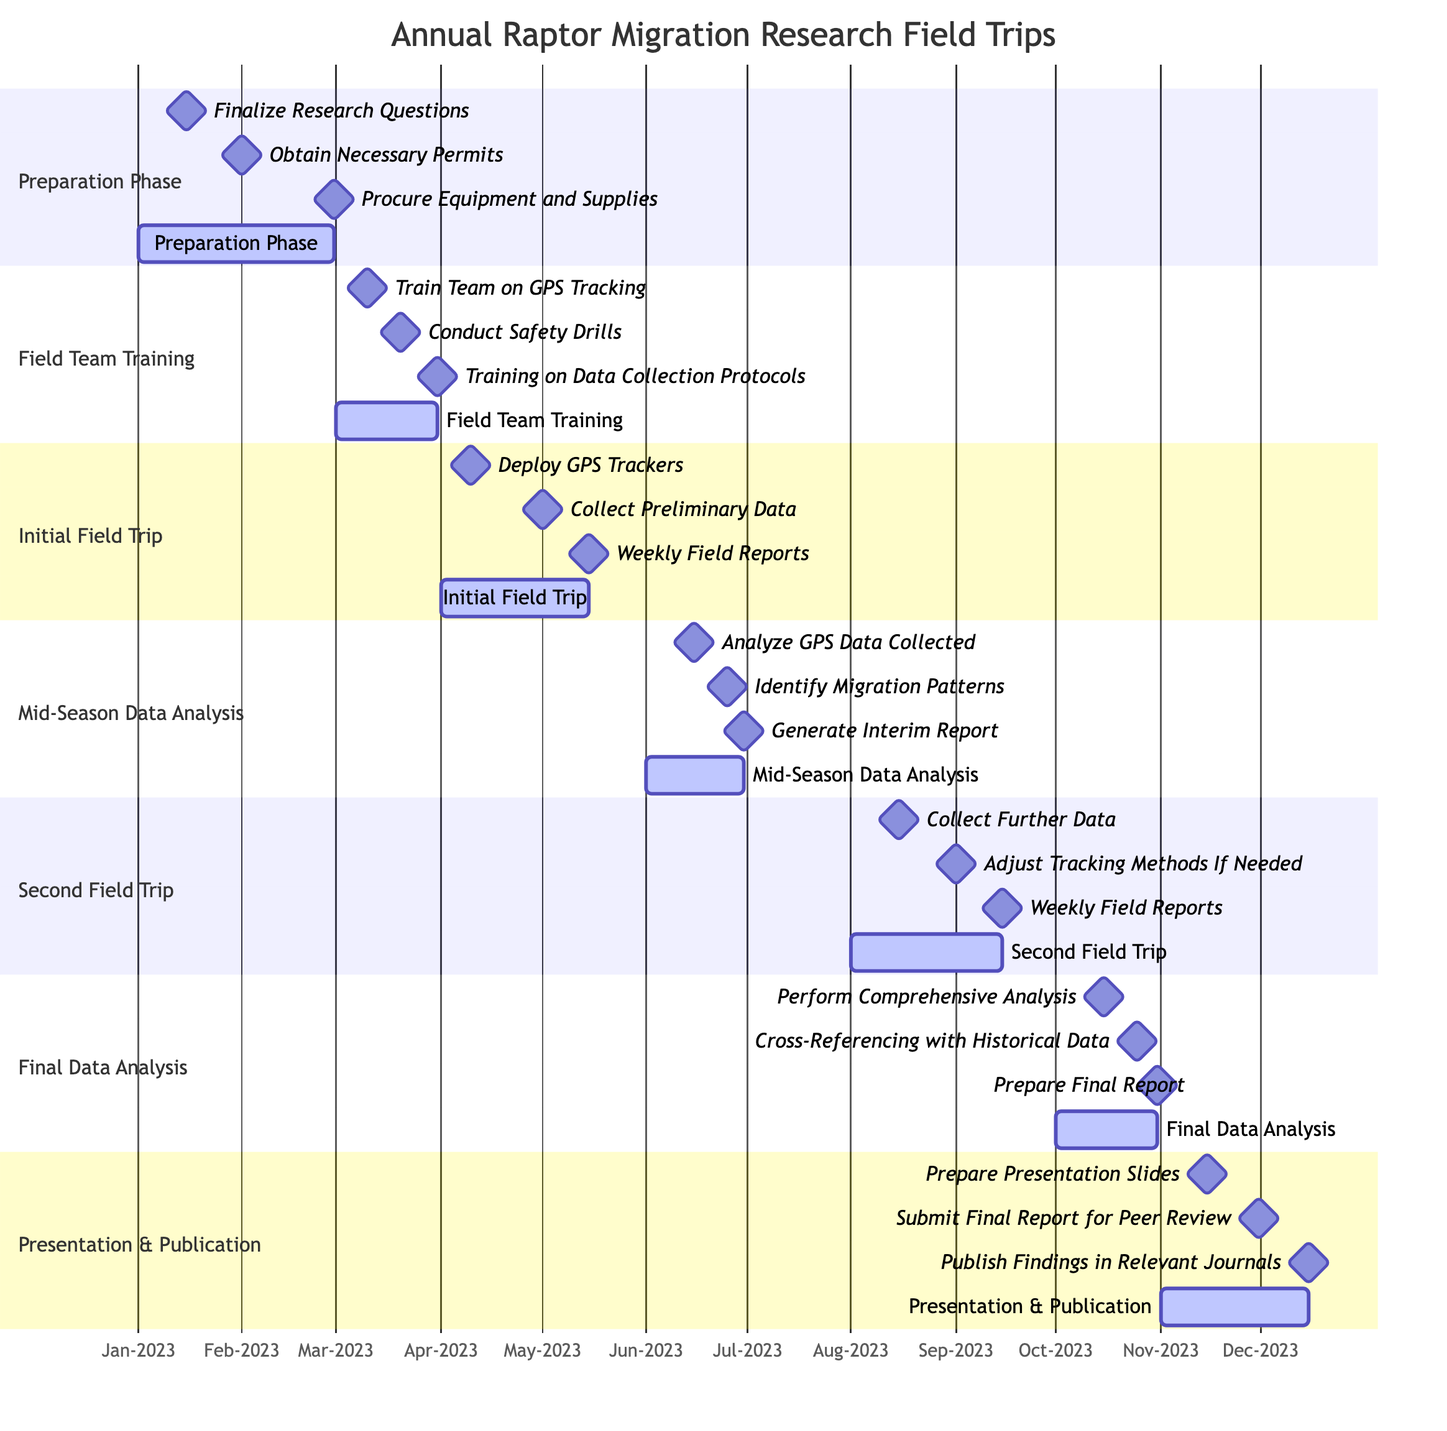What's the total number of phases in the Gantt chart? The Gantt chart has six sections: Preparation Phase, Field Team Training, Initial Field Trip, Mid-Season Data Analysis, Second Field Trip, Final Data Analysis, and Presentation & Publication. Counting these sections gives a total of six phases.
Answer: 6 What is the duration of the Initial Field Trip? The Initial Field Trip starts on April 1, 2023, and ends on May 15, 2023. The duration can be calculated from the start to the end date, which amounts to 45 days (15 days in April plus 15 days in May).
Answer: 45 days What milestone is scheduled for June 15, 2023? On June 15, 2023, the milestone "Preliminary GPS Data Analyzed" is scheduled as part of the Mid-Season Data Analysis. This can be confirmed by locating the date within that specific section of the Gantt chart.
Answer: Preliminary GPS Data Analyzed How many deliverables are there during the Field Team Training phase? The Field Team Training phase lists three deliverables: "Train Team on GPS Tracking," "Conduct Safety Drills," and "Training on Data Collection Protocols." Counting these items provides the total.
Answer: 3 Which deliverable is due immediately after the Second Field Trip? After the Second Field Trip, the deliverable is "Collect Further Data." This corresponds directly to the task in the Gantt chart as well as the sequencing of phases, thus identifying it clearly.
Answer: Collect Further Data When is the Final Report draft expected to be completed? The Final Report draft is expected to be completed by October 31, 2023, as indicated in the Final Data Analysis section of the Gantt chart. The deadline aligns with the end date of that section, making it clear.
Answer: October 31, 2023 Which phase includes the "Submit Final Report for Peer Review" milestone? The milestone "Submit Final Report for Peer Review" occurs in the Presentation & Publication phase. Examining the milestones listed within this phase confirms whereabouts of the specific milestone in the visual representation.
Answer: Presentation & Publication What is the timeframe for the Mid-Season Data Analysis? The Mid-Season Data Analysis timeframe is from June 1, 2023, to June 30, 2023. This is gathered from the section header and the specific dates marked under that section, aligning the start and end clearly.
Answer: June 1, 2023 - June 30, 2023 